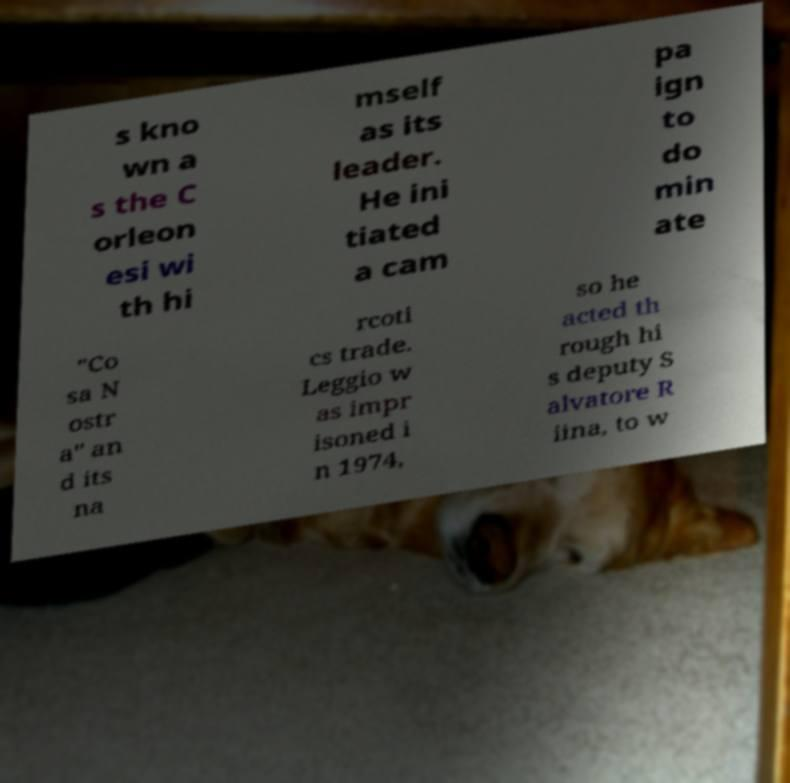What messages or text are displayed in this image? I need them in a readable, typed format. s kno wn a s the C orleon esi wi th hi mself as its leader. He ini tiated a cam pa ign to do min ate "Co sa N ostr a" an d its na rcoti cs trade. Leggio w as impr isoned i n 1974, so he acted th rough hi s deputy S alvatore R iina, to w 